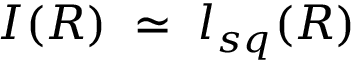Convert formula to latex. <formula><loc_0><loc_0><loc_500><loc_500>I ( R ) \, \simeq \, l _ { s q } ( R )</formula> 